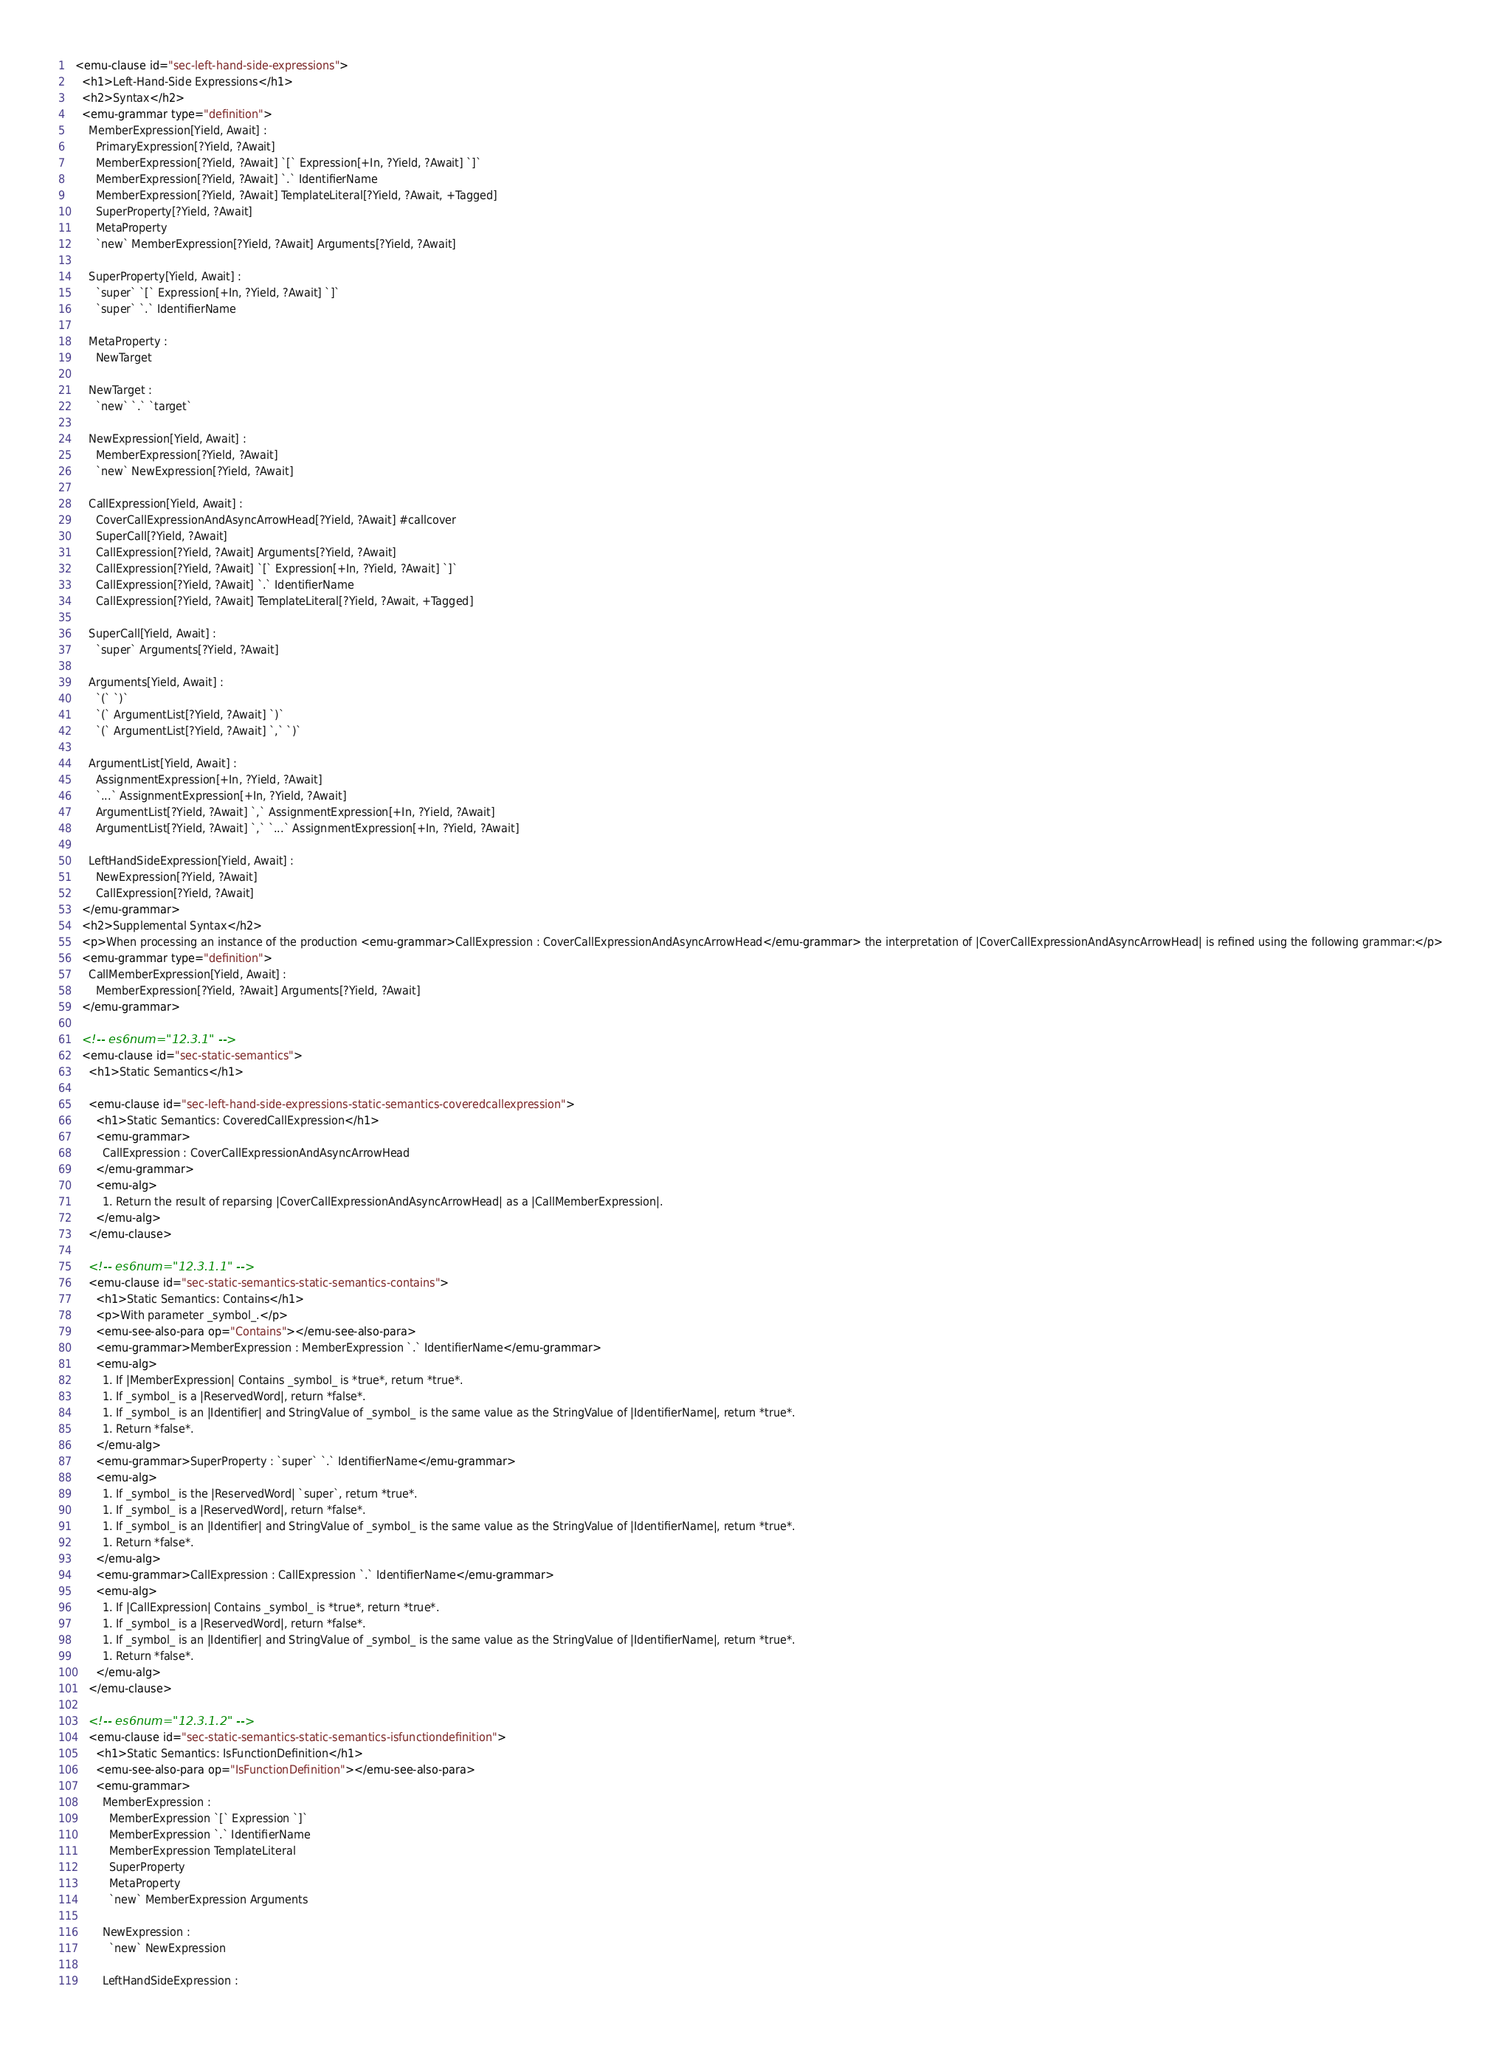<code> <loc_0><loc_0><loc_500><loc_500><_HTML_>  <emu-clause id="sec-left-hand-side-expressions">
    <h1>Left-Hand-Side Expressions</h1>
    <h2>Syntax</h2>
    <emu-grammar type="definition">
      MemberExpression[Yield, Await] :
        PrimaryExpression[?Yield, ?Await]
        MemberExpression[?Yield, ?Await] `[` Expression[+In, ?Yield, ?Await] `]`
        MemberExpression[?Yield, ?Await] `.` IdentifierName
        MemberExpression[?Yield, ?Await] TemplateLiteral[?Yield, ?Await, +Tagged]
        SuperProperty[?Yield, ?Await]
        MetaProperty
        `new` MemberExpression[?Yield, ?Await] Arguments[?Yield, ?Await]

      SuperProperty[Yield, Await] :
        `super` `[` Expression[+In, ?Yield, ?Await] `]`
        `super` `.` IdentifierName

      MetaProperty :
        NewTarget

      NewTarget :
        `new` `.` `target`

      NewExpression[Yield, Await] :
        MemberExpression[?Yield, ?Await]
        `new` NewExpression[?Yield, ?Await]

      CallExpression[Yield, Await] :
        CoverCallExpressionAndAsyncArrowHead[?Yield, ?Await] #callcover
        SuperCall[?Yield, ?Await]
        CallExpression[?Yield, ?Await] Arguments[?Yield, ?Await]
        CallExpression[?Yield, ?Await] `[` Expression[+In, ?Yield, ?Await] `]`
        CallExpression[?Yield, ?Await] `.` IdentifierName
        CallExpression[?Yield, ?Await] TemplateLiteral[?Yield, ?Await, +Tagged]

      SuperCall[Yield, Await] :
        `super` Arguments[?Yield, ?Await]

      Arguments[Yield, Await] :
        `(` `)`
        `(` ArgumentList[?Yield, ?Await] `)`
        `(` ArgumentList[?Yield, ?Await] `,` `)`

      ArgumentList[Yield, Await] :
        AssignmentExpression[+In, ?Yield, ?Await]
        `...` AssignmentExpression[+In, ?Yield, ?Await]
        ArgumentList[?Yield, ?Await] `,` AssignmentExpression[+In, ?Yield, ?Await]
        ArgumentList[?Yield, ?Await] `,` `...` AssignmentExpression[+In, ?Yield, ?Await]

      LeftHandSideExpression[Yield, Await] :
        NewExpression[?Yield, ?Await]
        CallExpression[?Yield, ?Await]
    </emu-grammar>
    <h2>Supplemental Syntax</h2>
    <p>When processing an instance of the production <emu-grammar>CallExpression : CoverCallExpressionAndAsyncArrowHead</emu-grammar> the interpretation of |CoverCallExpressionAndAsyncArrowHead| is refined using the following grammar:</p>
    <emu-grammar type="definition">
      CallMemberExpression[Yield, Await] :
        MemberExpression[?Yield, ?Await] Arguments[?Yield, ?Await]
    </emu-grammar>

    <!-- es6num="12.3.1" -->
    <emu-clause id="sec-static-semantics">
      <h1>Static Semantics</h1>

      <emu-clause id="sec-left-hand-side-expressions-static-semantics-coveredcallexpression">
        <h1>Static Semantics: CoveredCallExpression</h1>
        <emu-grammar>
          CallExpression : CoverCallExpressionAndAsyncArrowHead
        </emu-grammar>
        <emu-alg>
          1. Return the result of reparsing |CoverCallExpressionAndAsyncArrowHead| as a |CallMemberExpression|.
        </emu-alg>
      </emu-clause>

      <!-- es6num="12.3.1.1" -->
      <emu-clause id="sec-static-semantics-static-semantics-contains">
        <h1>Static Semantics: Contains</h1>
        <p>With parameter _symbol_.</p>
        <emu-see-also-para op="Contains"></emu-see-also-para>
        <emu-grammar>MemberExpression : MemberExpression `.` IdentifierName</emu-grammar>
        <emu-alg>
          1. If |MemberExpression| Contains _symbol_ is *true*, return *true*.
          1. If _symbol_ is a |ReservedWord|, return *false*.
          1. If _symbol_ is an |Identifier| and StringValue of _symbol_ is the same value as the StringValue of |IdentifierName|, return *true*.
          1. Return *false*.
        </emu-alg>
        <emu-grammar>SuperProperty : `super` `.` IdentifierName</emu-grammar>
        <emu-alg>
          1. If _symbol_ is the |ReservedWord| `super`, return *true*.
          1. If _symbol_ is a |ReservedWord|, return *false*.
          1. If _symbol_ is an |Identifier| and StringValue of _symbol_ is the same value as the StringValue of |IdentifierName|, return *true*.
          1. Return *false*.
        </emu-alg>
        <emu-grammar>CallExpression : CallExpression `.` IdentifierName</emu-grammar>
        <emu-alg>
          1. If |CallExpression| Contains _symbol_ is *true*, return *true*.
          1. If _symbol_ is a |ReservedWord|, return *false*.
          1. If _symbol_ is an |Identifier| and StringValue of _symbol_ is the same value as the StringValue of |IdentifierName|, return *true*.
          1. Return *false*.
        </emu-alg>
      </emu-clause>

      <!-- es6num="12.3.1.2" -->
      <emu-clause id="sec-static-semantics-static-semantics-isfunctiondefinition">
        <h1>Static Semantics: IsFunctionDefinition</h1>
        <emu-see-also-para op="IsFunctionDefinition"></emu-see-also-para>
        <emu-grammar>
          MemberExpression :
            MemberExpression `[` Expression `]`
            MemberExpression `.` IdentifierName
            MemberExpression TemplateLiteral
            SuperProperty
            MetaProperty
            `new` MemberExpression Arguments

          NewExpression :
            `new` NewExpression

          LeftHandSideExpression :</code> 